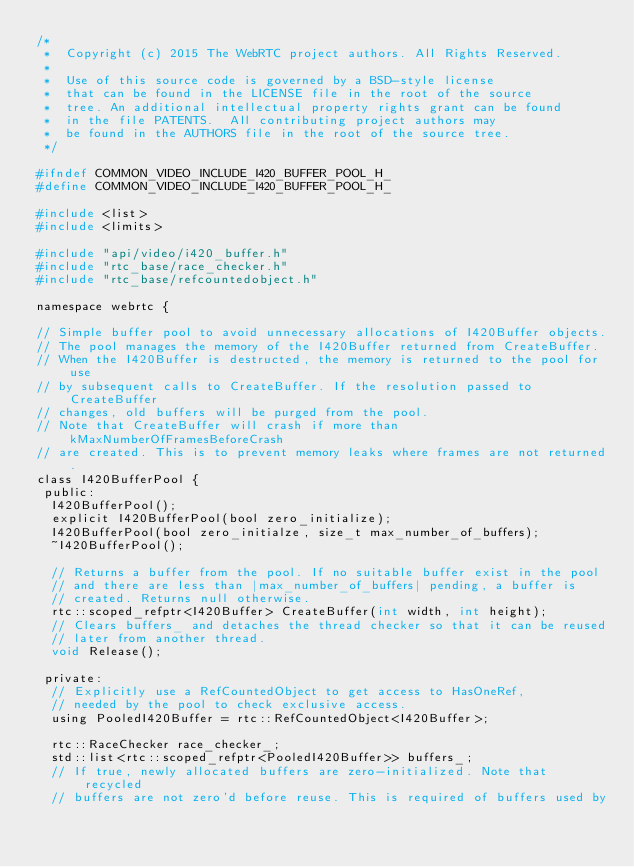Convert code to text. <code><loc_0><loc_0><loc_500><loc_500><_C_>/*
 *  Copyright (c) 2015 The WebRTC project authors. All Rights Reserved.
 *
 *  Use of this source code is governed by a BSD-style license
 *  that can be found in the LICENSE file in the root of the source
 *  tree. An additional intellectual property rights grant can be found
 *  in the file PATENTS.  All contributing project authors may
 *  be found in the AUTHORS file in the root of the source tree.
 */

#ifndef COMMON_VIDEO_INCLUDE_I420_BUFFER_POOL_H_
#define COMMON_VIDEO_INCLUDE_I420_BUFFER_POOL_H_

#include <list>
#include <limits>

#include "api/video/i420_buffer.h"
#include "rtc_base/race_checker.h"
#include "rtc_base/refcountedobject.h"

namespace webrtc {

// Simple buffer pool to avoid unnecessary allocations of I420Buffer objects.
// The pool manages the memory of the I420Buffer returned from CreateBuffer.
// When the I420Buffer is destructed, the memory is returned to the pool for use
// by subsequent calls to CreateBuffer. If the resolution passed to CreateBuffer
// changes, old buffers will be purged from the pool.
// Note that CreateBuffer will crash if more than kMaxNumberOfFramesBeforeCrash
// are created. This is to prevent memory leaks where frames are not returned.
class I420BufferPool {
 public:
  I420BufferPool();
  explicit I420BufferPool(bool zero_initialize);
  I420BufferPool(bool zero_initialze, size_t max_number_of_buffers);
  ~I420BufferPool();

  // Returns a buffer from the pool. If no suitable buffer exist in the pool
  // and there are less than |max_number_of_buffers| pending, a buffer is
  // created. Returns null otherwise.
  rtc::scoped_refptr<I420Buffer> CreateBuffer(int width, int height);
  // Clears buffers_ and detaches the thread checker so that it can be reused
  // later from another thread.
  void Release();

 private:
  // Explicitly use a RefCountedObject to get access to HasOneRef,
  // needed by the pool to check exclusive access.
  using PooledI420Buffer = rtc::RefCountedObject<I420Buffer>;

  rtc::RaceChecker race_checker_;
  std::list<rtc::scoped_refptr<PooledI420Buffer>> buffers_;
  // If true, newly allocated buffers are zero-initialized. Note that recycled
  // buffers are not zero'd before reuse. This is required of buffers used by</code> 